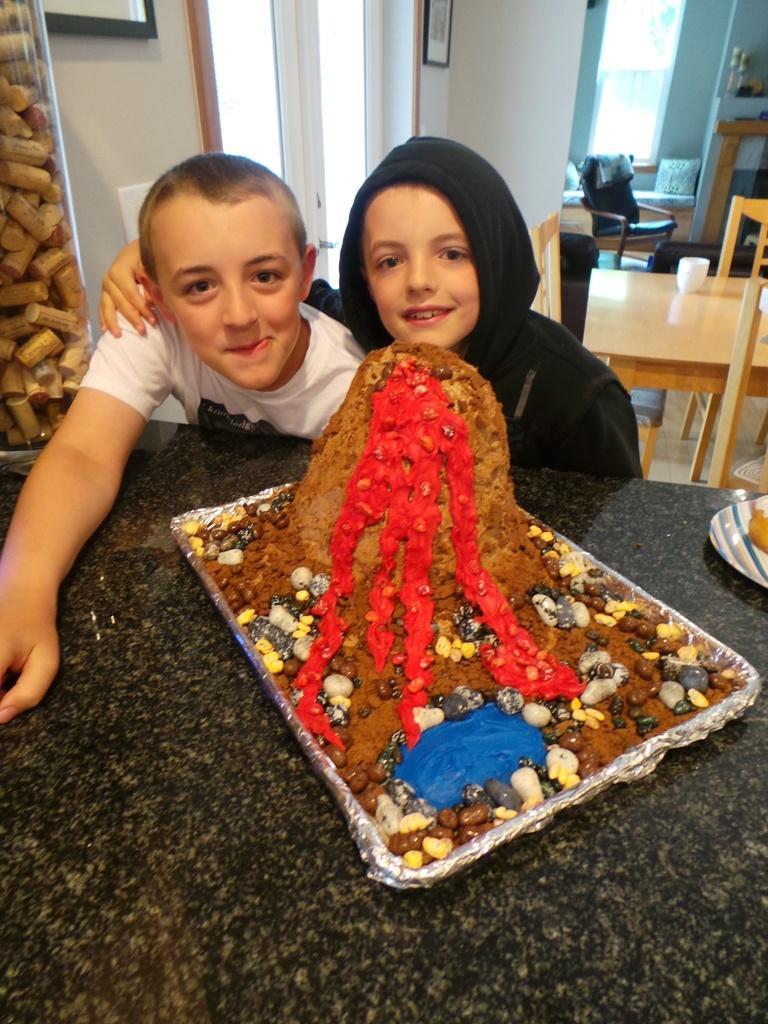Could you give a brief overview of what you see in this image? These 2 kids are highlighted in this picture. On this table there is a tray with food and plate. In this room we can able to see pictures on wall, chairs, tables, and bed with pillow. On this table there is a cup. On this chair there is a cloth. 